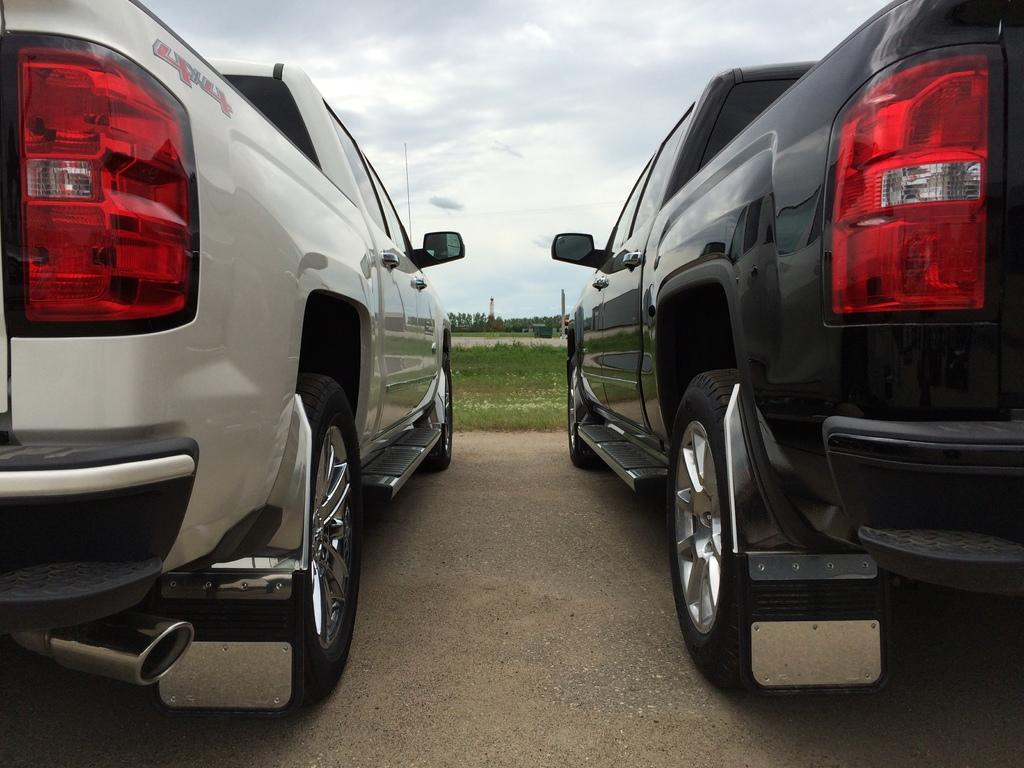How many vehicles are in the image? There are two vehicles in the image. What are the colors of the vehicles? One vehicle is white, and the other is black. What can be seen in the background of the image? There are trees and poles visible in the background. What is the color of the sky in the image? The sky is blue and white in color. How many passengers are in the black vehicle in the image? There is no information about passengers in the image, as it only shows the vehicles and their colors. 